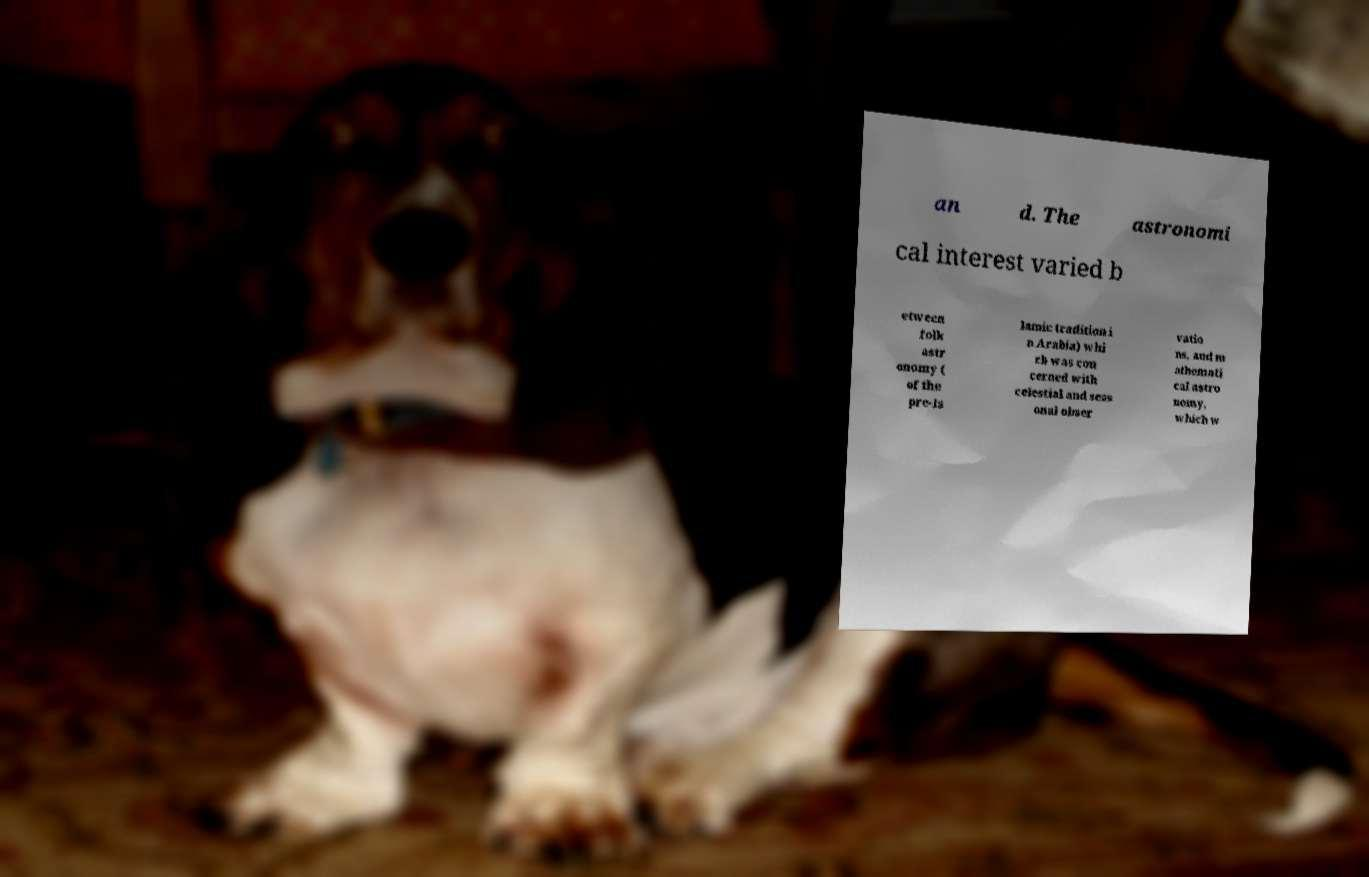Could you extract and type out the text from this image? an d. The astronomi cal interest varied b etween folk astr onomy ( of the pre-Is lamic tradition i n Arabia) whi ch was con cerned with celestial and seas onal obser vatio ns, and m athemati cal astro nomy, which w 